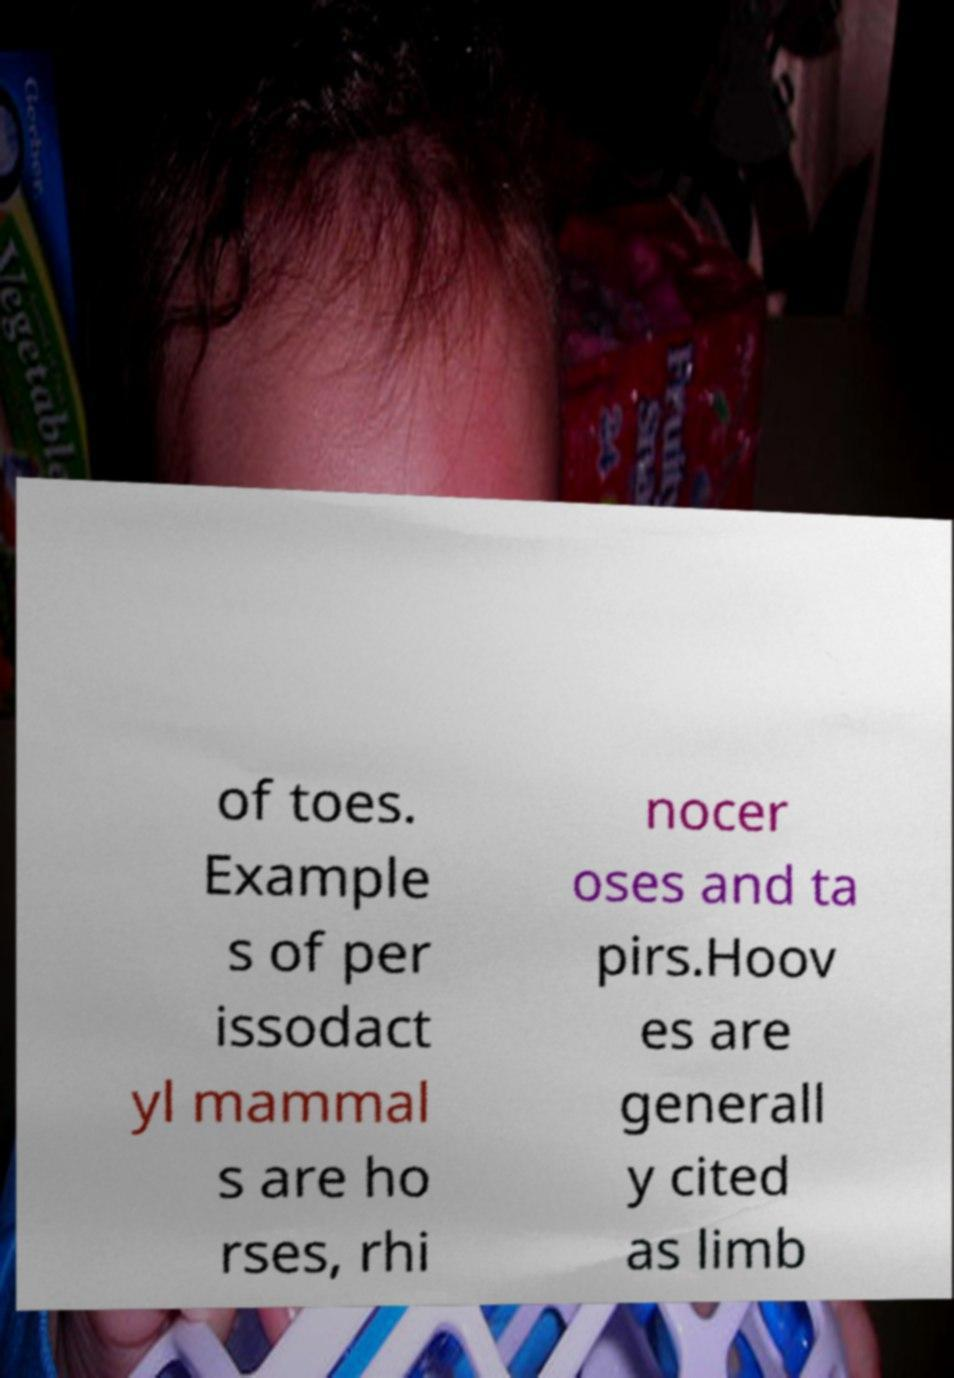There's text embedded in this image that I need extracted. Can you transcribe it verbatim? of toes. Example s of per issodact yl mammal s are ho rses, rhi nocer oses and ta pirs.Hoov es are generall y cited as limb 